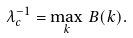Convert formula to latex. <formula><loc_0><loc_0><loc_500><loc_500>\lambda _ { c } ^ { - 1 } = \max _ { k } \, B ( k ) .</formula> 